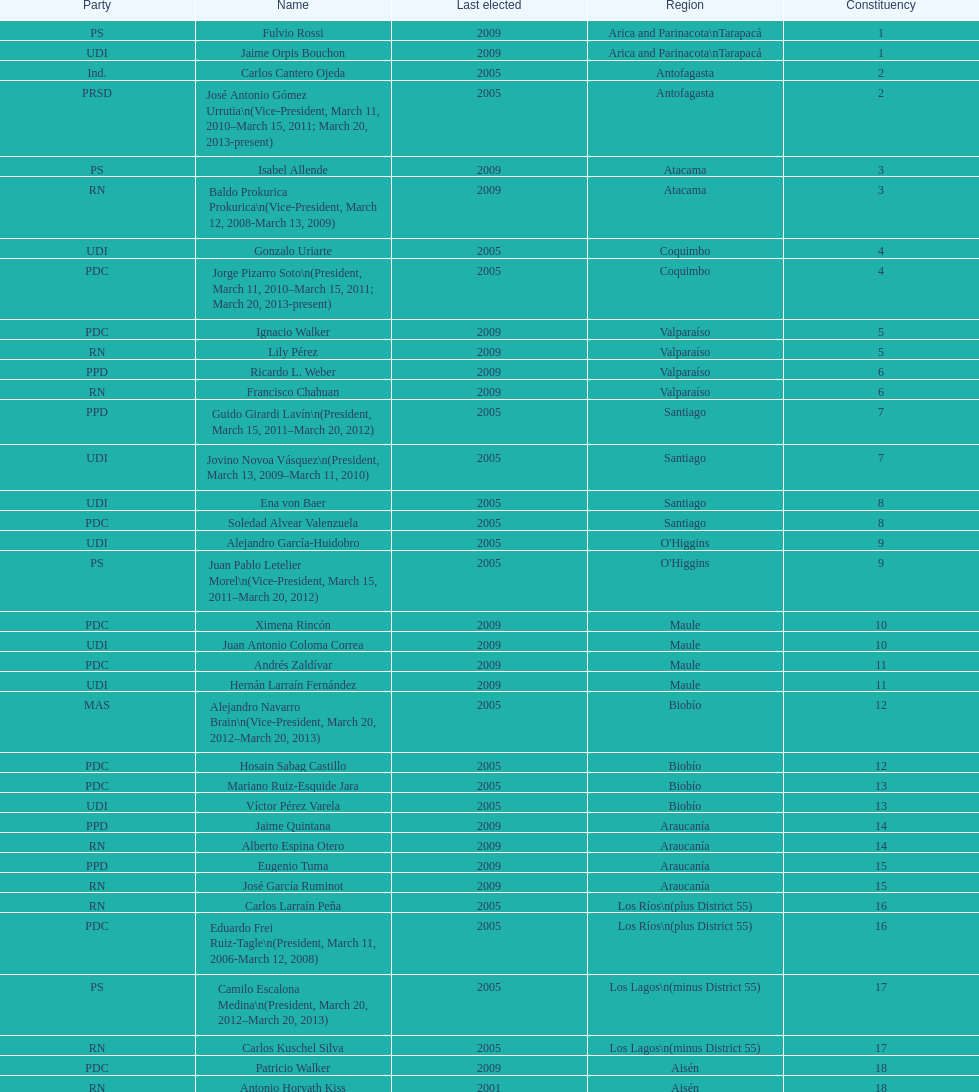Could you help me parse every detail presented in this table? {'header': ['Party', 'Name', 'Last elected', 'Region', 'Constituency'], 'rows': [['PS', 'Fulvio Rossi', '2009', 'Arica and Parinacota\\nTarapacá', '1'], ['UDI', 'Jaime Orpis Bouchon', '2009', 'Arica and Parinacota\\nTarapacá', '1'], ['Ind.', 'Carlos Cantero Ojeda', '2005', 'Antofagasta', '2'], ['PRSD', 'José Antonio Gómez Urrutia\\n(Vice-President, March 11, 2010–March 15, 2011; March 20, 2013-present)', '2005', 'Antofagasta', '2'], ['PS', 'Isabel Allende', '2009', 'Atacama', '3'], ['RN', 'Baldo Prokurica Prokurica\\n(Vice-President, March 12, 2008-March 13, 2009)', '2009', 'Atacama', '3'], ['UDI', 'Gonzalo Uriarte', '2005', 'Coquimbo', '4'], ['PDC', 'Jorge Pizarro Soto\\n(President, March 11, 2010–March 15, 2011; March 20, 2013-present)', '2005', 'Coquimbo', '4'], ['PDC', 'Ignacio Walker', '2009', 'Valparaíso', '5'], ['RN', 'Lily Pérez', '2009', 'Valparaíso', '5'], ['PPD', 'Ricardo L. Weber', '2009', 'Valparaíso', '6'], ['RN', 'Francisco Chahuan', '2009', 'Valparaíso', '6'], ['PPD', 'Guido Girardi Lavín\\n(President, March 15, 2011–March 20, 2012)', '2005', 'Santiago', '7'], ['UDI', 'Jovino Novoa Vásquez\\n(President, March 13, 2009–March 11, 2010)', '2005', 'Santiago', '7'], ['UDI', 'Ena von Baer', '2005', 'Santiago', '8'], ['PDC', 'Soledad Alvear Valenzuela', '2005', 'Santiago', '8'], ['UDI', 'Alejandro García-Huidobro', '2005', "O'Higgins", '9'], ['PS', 'Juan Pablo Letelier Morel\\n(Vice-President, March 15, 2011–March 20, 2012)', '2005', "O'Higgins", '9'], ['PDC', 'Ximena Rincón', '2009', 'Maule', '10'], ['UDI', 'Juan Antonio Coloma Correa', '2009', 'Maule', '10'], ['PDC', 'Andrés Zaldívar', '2009', 'Maule', '11'], ['UDI', 'Hernán Larraín Fernández', '2009', 'Maule', '11'], ['MAS', 'Alejandro Navarro Brain\\n(Vice-President, March 20, 2012–March 20, 2013)', '2005', 'Biobío', '12'], ['PDC', 'Hosain Sabag Castillo', '2005', 'Biobío', '12'], ['PDC', 'Mariano Ruiz-Esquide Jara', '2005', 'Biobío', '13'], ['UDI', 'Víctor Pérez Varela', '2005', 'Biobío', '13'], ['PPD', 'Jaime Quintana', '2009', 'Araucanía', '14'], ['RN', 'Alberto Espina Otero', '2009', 'Araucanía', '14'], ['PPD', 'Eugenio Tuma', '2009', 'Araucanía', '15'], ['RN', 'José García Ruminot', '2009', 'Araucanía', '15'], ['RN', 'Carlos Larraín Peña', '2005', 'Los Ríos\\n(plus District 55)', '16'], ['PDC', 'Eduardo Frei Ruiz-Tagle\\n(President, March 11, 2006-March 12, 2008)', '2005', 'Los Ríos\\n(plus District 55)', '16'], ['PS', 'Camilo Escalona Medina\\n(President, March 20, 2012–March 20, 2013)', '2005', 'Los Lagos\\n(minus District 55)', '17'], ['RN', 'Carlos Kuschel Silva', '2005', 'Los Lagos\\n(minus District 55)', '17'], ['PDC', 'Patricio Walker', '2009', 'Aisén', '18'], ['RN', 'Antonio Horvath Kiss', '2001', 'Aisén', '18'], ['Ind.', 'Carlos Bianchi Chelech\\n(Vice-President, March 13, 2009–March 11, 2010)', '2005', 'Magallanes', '19'], ['PS', 'Pedro Muñoz Aburto', '2005', 'Magallanes', '19']]} How long was baldo prokurica prokurica vice-president? 1 year. 